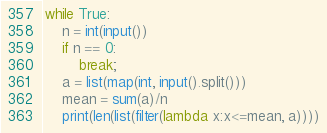Convert code to text. <code><loc_0><loc_0><loc_500><loc_500><_Python_>while True:
    n = int(input())
    if n == 0:
        break;
    a = list(map(int, input().split()))
    mean = sum(a)/n
    print(len(list(filter(lambda x:x<=mean, a))))

</code> 